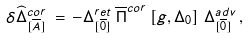Convert formula to latex. <formula><loc_0><loc_0><loc_500><loc_500>\delta \widehat { \Delta } ^ { c o r } _ { [ \overline { A } ] } \, = \, - { \Delta } ^ { r e t } _ { [ \overline { 0 } ] } \, \overline { \Pi } ^ { c o r } \left [ g , \Delta _ { 0 } \right ] \, { \Delta } ^ { a d v } _ { [ \overline { 0 } ] } \, ,</formula> 